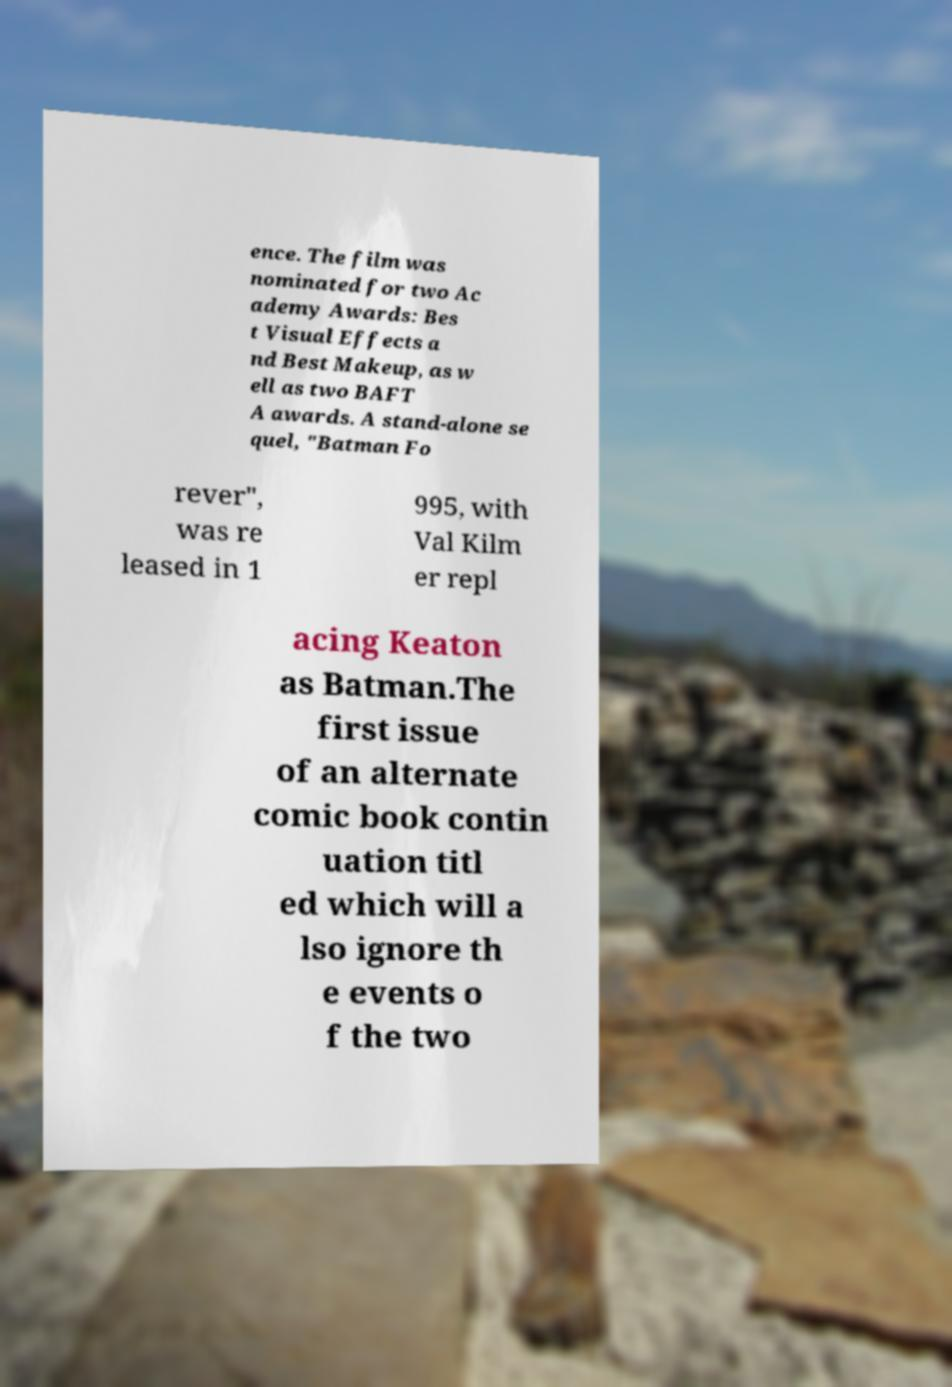Please read and relay the text visible in this image. What does it say? ence. The film was nominated for two Ac ademy Awards: Bes t Visual Effects a nd Best Makeup, as w ell as two BAFT A awards. A stand-alone se quel, "Batman Fo rever", was re leased in 1 995, with Val Kilm er repl acing Keaton as Batman.The first issue of an alternate comic book contin uation titl ed which will a lso ignore th e events o f the two 